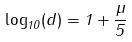<formula> <loc_0><loc_0><loc_500><loc_500>\log _ { 1 0 } ( d ) = 1 + \frac { \mu } { 5 }</formula> 